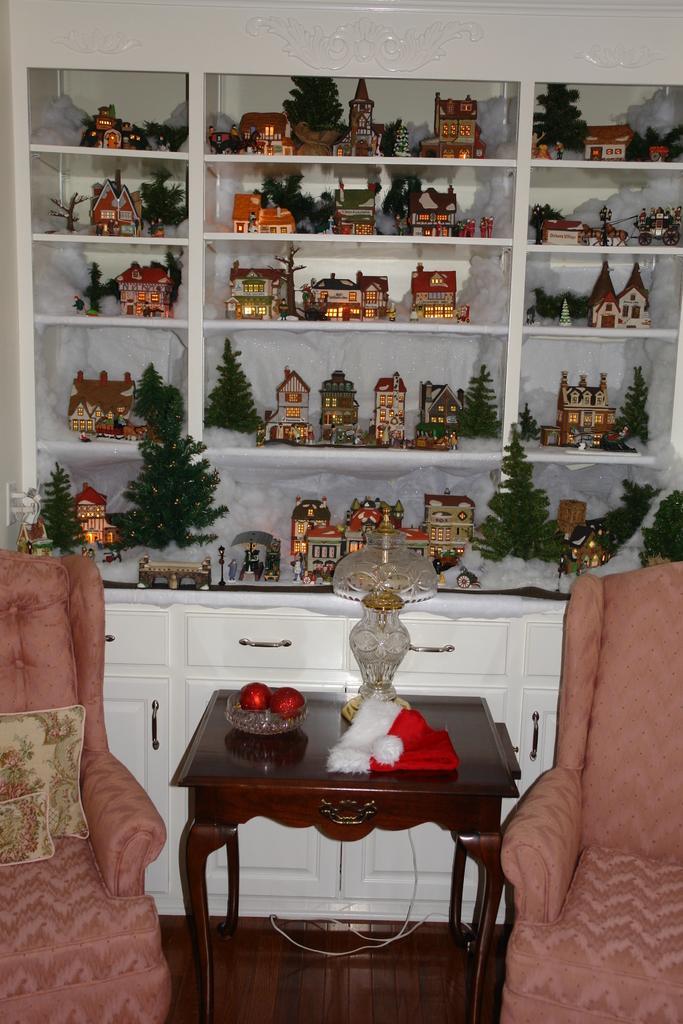How would you summarize this image in a sentence or two? This image is taken inside a room. There are two chairs. There is a table. At the background of the image there is a shelf and there are many objects in it. 